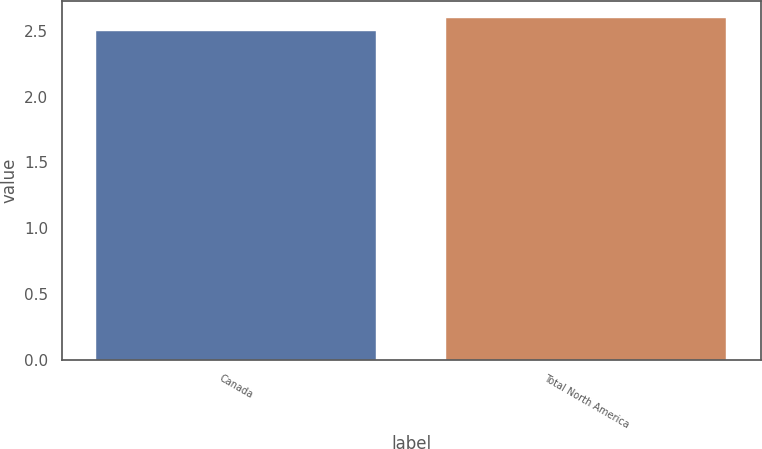<chart> <loc_0><loc_0><loc_500><loc_500><bar_chart><fcel>Canada<fcel>Total North America<nl><fcel>2.5<fcel>2.6<nl></chart> 